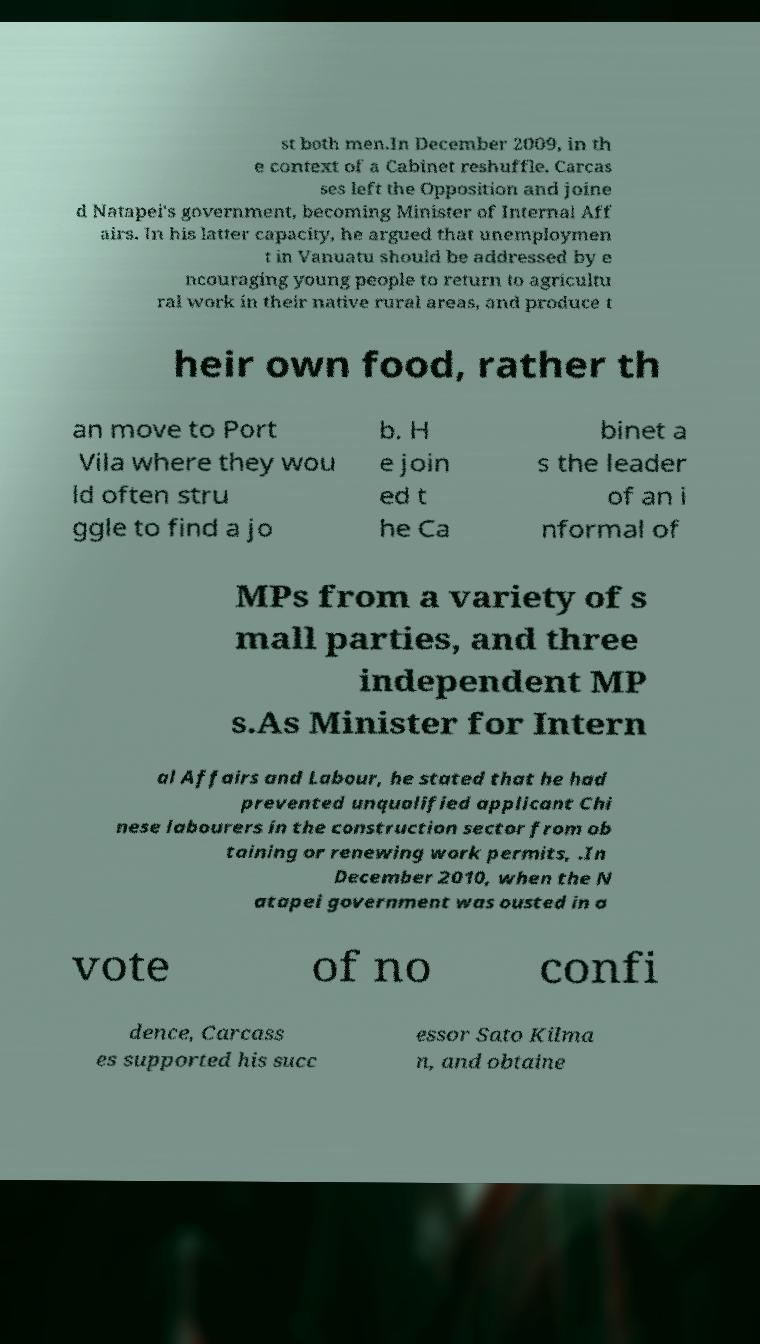Could you extract and type out the text from this image? st both men.In December 2009, in th e context of a Cabinet reshuffle, Carcas ses left the Opposition and joine d Natapei's government, becoming Minister of Internal Aff airs. In his latter capacity, he argued that unemploymen t in Vanuatu should be addressed by e ncouraging young people to return to agricultu ral work in their native rural areas, and produce t heir own food, rather th an move to Port Vila where they wou ld often stru ggle to find a jo b. H e join ed t he Ca binet a s the leader of an i nformal of MPs from a variety of s mall parties, and three independent MP s.As Minister for Intern al Affairs and Labour, he stated that he had prevented unqualified applicant Chi nese labourers in the construction sector from ob taining or renewing work permits, .In December 2010, when the N atapei government was ousted in a vote of no confi dence, Carcass es supported his succ essor Sato Kilma n, and obtaine 